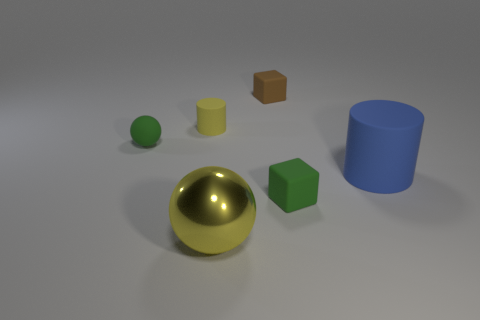Add 4 big gray cylinders. How many objects exist? 10 Subtract all cubes. How many objects are left? 4 Subtract 0 blue spheres. How many objects are left? 6 Subtract all small blue cylinders. Subtract all brown rubber things. How many objects are left? 5 Add 3 spheres. How many spheres are left? 5 Add 6 green blocks. How many green blocks exist? 7 